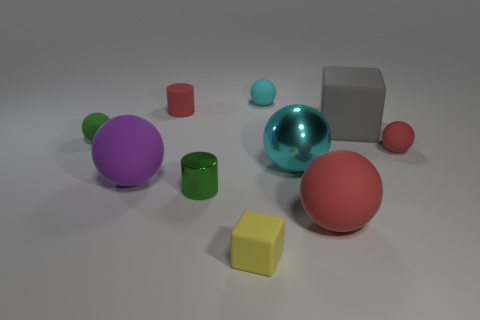What color is the block that is the same size as the shiny cylinder?
Your response must be concise. Yellow. Does the green object that is in front of the big purple rubber ball have the same material as the red thing that is on the left side of the large metallic thing?
Your answer should be compact. No. How big is the red thing that is to the left of the cube in front of the big purple thing?
Ensure brevity in your answer.  Small. There is a green thing that is behind the green cylinder; what is it made of?
Offer a terse response. Rubber. How many things are tiny red rubber objects behind the small red ball or tiny rubber objects behind the purple rubber thing?
Your response must be concise. 4. There is another small object that is the same shape as the gray thing; what is its material?
Offer a terse response. Rubber. There is a tiny thing on the right side of the tiny cyan rubber thing; is its color the same as the large ball in front of the purple rubber sphere?
Keep it short and to the point. Yes. Are there any cyan blocks of the same size as the gray matte object?
Your answer should be very brief. No. What is the material of the small thing that is both behind the big gray matte object and on the left side of the tiny yellow rubber object?
Give a very brief answer. Rubber. How many matte things are either big red objects or gray blocks?
Give a very brief answer. 2. 